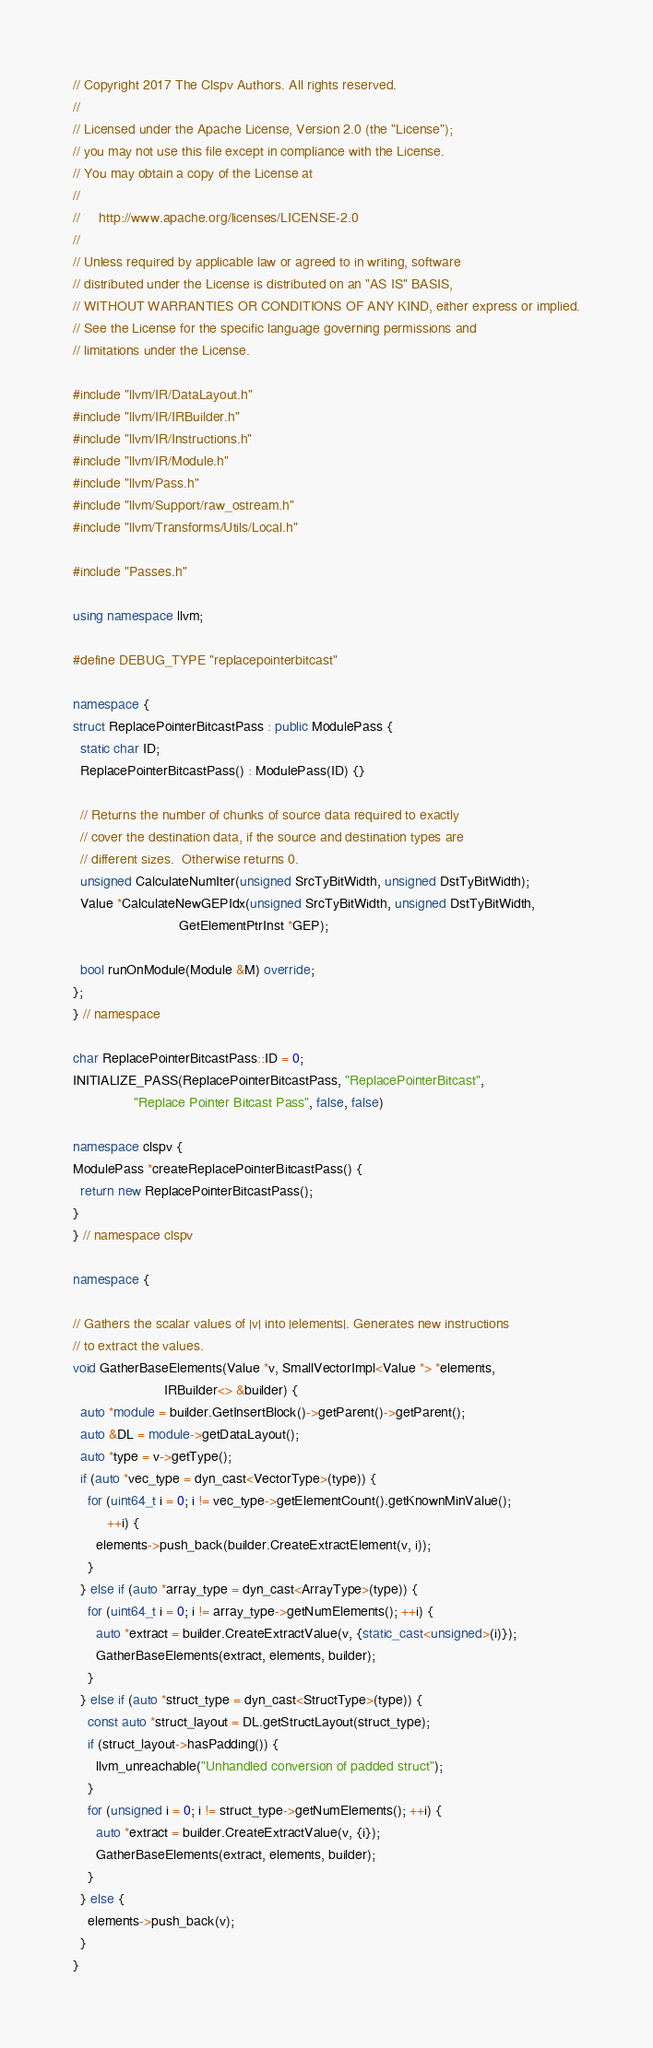Convert code to text. <code><loc_0><loc_0><loc_500><loc_500><_C++_>// Copyright 2017 The Clspv Authors. All rights reserved.
//
// Licensed under the Apache License, Version 2.0 (the "License");
// you may not use this file except in compliance with the License.
// You may obtain a copy of the License at
//
//     http://www.apache.org/licenses/LICENSE-2.0
//
// Unless required by applicable law or agreed to in writing, software
// distributed under the License is distributed on an "AS IS" BASIS,
// WITHOUT WARRANTIES OR CONDITIONS OF ANY KIND, either express or implied.
// See the License for the specific language governing permissions and
// limitations under the License.

#include "llvm/IR/DataLayout.h"
#include "llvm/IR/IRBuilder.h"
#include "llvm/IR/Instructions.h"
#include "llvm/IR/Module.h"
#include "llvm/Pass.h"
#include "llvm/Support/raw_ostream.h"
#include "llvm/Transforms/Utils/Local.h"

#include "Passes.h"

using namespace llvm;

#define DEBUG_TYPE "replacepointerbitcast"

namespace {
struct ReplacePointerBitcastPass : public ModulePass {
  static char ID;
  ReplacePointerBitcastPass() : ModulePass(ID) {}

  // Returns the number of chunks of source data required to exactly
  // cover the destination data, if the source and destination types are
  // different sizes.  Otherwise returns 0.
  unsigned CalculateNumIter(unsigned SrcTyBitWidth, unsigned DstTyBitWidth);
  Value *CalculateNewGEPIdx(unsigned SrcTyBitWidth, unsigned DstTyBitWidth,
                            GetElementPtrInst *GEP);

  bool runOnModule(Module &M) override;
};
} // namespace

char ReplacePointerBitcastPass::ID = 0;
INITIALIZE_PASS(ReplacePointerBitcastPass, "ReplacePointerBitcast",
                "Replace Pointer Bitcast Pass", false, false)

namespace clspv {
ModulePass *createReplacePointerBitcastPass() {
  return new ReplacePointerBitcastPass();
}
} // namespace clspv

namespace {

// Gathers the scalar values of |v| into |elements|. Generates new instructions
// to extract the values.
void GatherBaseElements(Value *v, SmallVectorImpl<Value *> *elements,
                        IRBuilder<> &builder) {
  auto *module = builder.GetInsertBlock()->getParent()->getParent();
  auto &DL = module->getDataLayout();
  auto *type = v->getType();
  if (auto *vec_type = dyn_cast<VectorType>(type)) {
    for (uint64_t i = 0; i != vec_type->getElementCount().getKnownMinValue();
         ++i) {
      elements->push_back(builder.CreateExtractElement(v, i));
    }
  } else if (auto *array_type = dyn_cast<ArrayType>(type)) {
    for (uint64_t i = 0; i != array_type->getNumElements(); ++i) {
      auto *extract = builder.CreateExtractValue(v, {static_cast<unsigned>(i)});
      GatherBaseElements(extract, elements, builder);
    }
  } else if (auto *struct_type = dyn_cast<StructType>(type)) {
    const auto *struct_layout = DL.getStructLayout(struct_type);
    if (struct_layout->hasPadding()) {
      llvm_unreachable("Unhandled conversion of padded struct");
    }
    for (unsigned i = 0; i != struct_type->getNumElements(); ++i) {
      auto *extract = builder.CreateExtractValue(v, {i});
      GatherBaseElements(extract, elements, builder);
    }
  } else {
    elements->push_back(v);
  }
}
</code> 